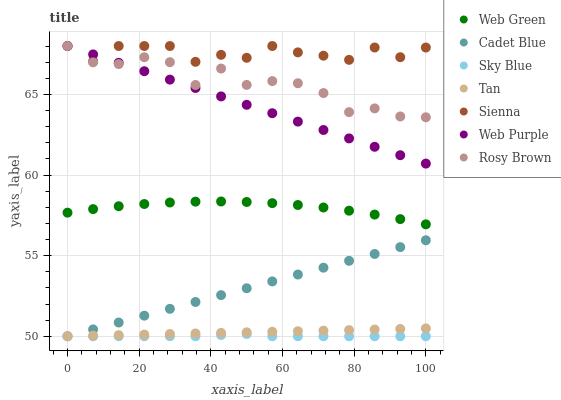Does Sky Blue have the minimum area under the curve?
Answer yes or no. Yes. Does Sienna have the maximum area under the curve?
Answer yes or no. Yes. Does Rosy Brown have the minimum area under the curve?
Answer yes or no. No. Does Rosy Brown have the maximum area under the curve?
Answer yes or no. No. Is Cadet Blue the smoothest?
Answer yes or no. Yes. Is Rosy Brown the roughest?
Answer yes or no. Yes. Is Web Green the smoothest?
Answer yes or no. No. Is Web Green the roughest?
Answer yes or no. No. Does Cadet Blue have the lowest value?
Answer yes or no. Yes. Does Rosy Brown have the lowest value?
Answer yes or no. No. Does Web Purple have the highest value?
Answer yes or no. Yes. Does Web Green have the highest value?
Answer yes or no. No. Is Sky Blue less than Web Green?
Answer yes or no. Yes. Is Rosy Brown greater than Web Green?
Answer yes or no. Yes. Does Sienna intersect Rosy Brown?
Answer yes or no. Yes. Is Sienna less than Rosy Brown?
Answer yes or no. No. Is Sienna greater than Rosy Brown?
Answer yes or no. No. Does Sky Blue intersect Web Green?
Answer yes or no. No. 